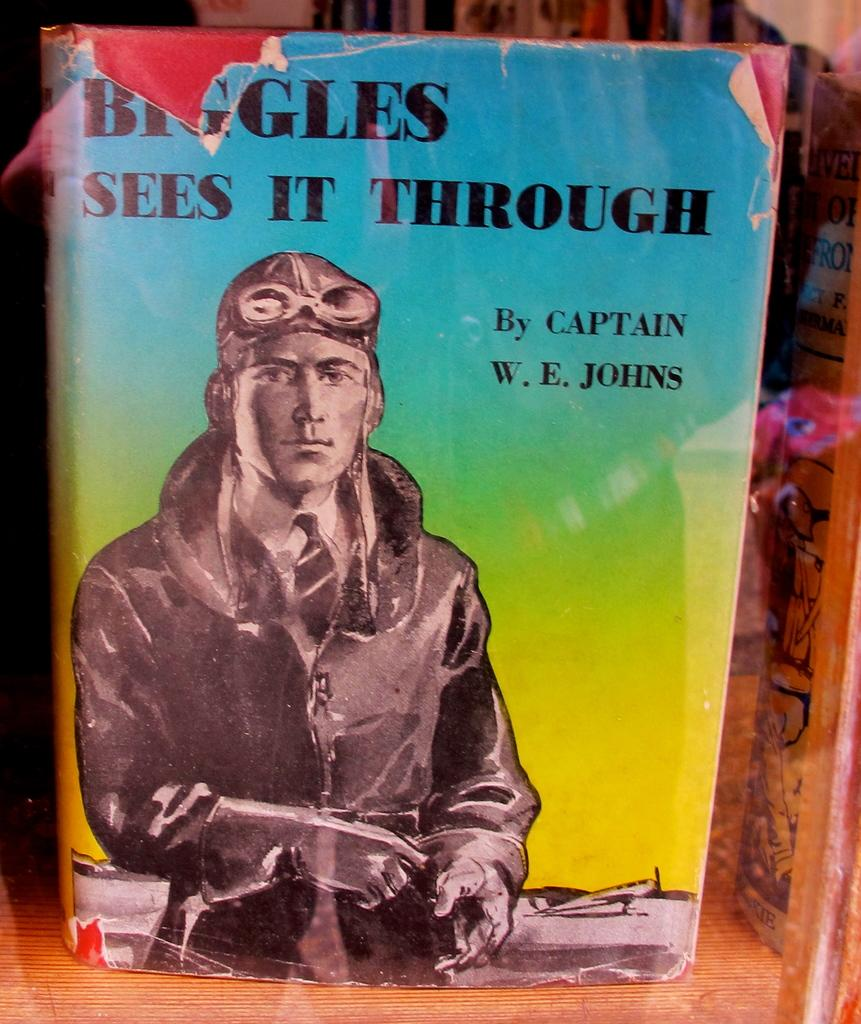<image>
Offer a succinct explanation of the picture presented. A colorful book written by Captain W. E. Johns. 